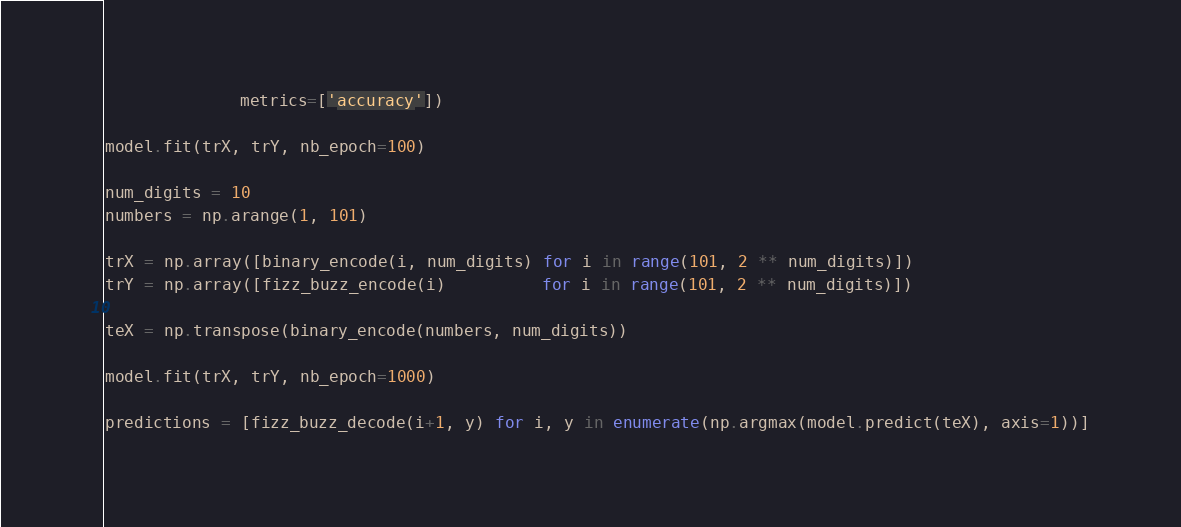Convert code to text. <code><loc_0><loc_0><loc_500><loc_500><_Python_>              metrics=['accuracy'])

model.fit(trX, trY, nb_epoch=100)

num_digits = 10
numbers = np.arange(1, 101)

trX = np.array([binary_encode(i, num_digits) for i in range(101, 2 ** num_digits)])
trY = np.array([fizz_buzz_encode(i)          for i in range(101, 2 ** num_digits)])

teX = np.transpose(binary_encode(numbers, num_digits))

model.fit(trX, trY, nb_epoch=1000)

predictions = [fizz_buzz_decode(i+1, y) for i, y in enumerate(np.argmax(model.predict(teX), axis=1))]
</code> 